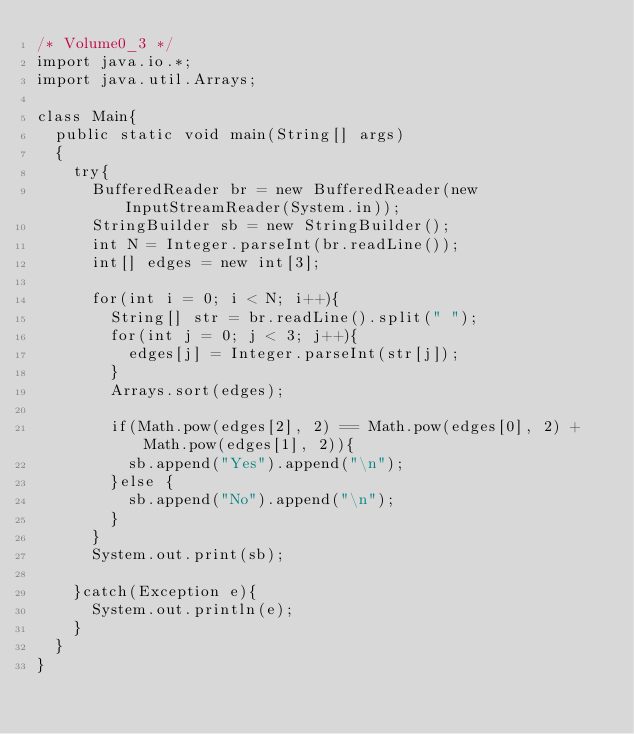Convert code to text. <code><loc_0><loc_0><loc_500><loc_500><_Java_>/* Volume0_3 */
import java.io.*;
import java.util.Arrays;

class Main{
  public static void main(String[] args)
  {
    try{
      BufferedReader br = new BufferedReader(new InputStreamReader(System.in));
      StringBuilder sb = new StringBuilder();
      int N = Integer.parseInt(br.readLine());
      int[] edges = new int[3];

      for(int i = 0; i < N; i++){
        String[] str = br.readLine().split(" ");
        for(int j = 0; j < 3; j++){
          edges[j] = Integer.parseInt(str[j]);
        }
        Arrays.sort(edges);

        if(Math.pow(edges[2], 2) == Math.pow(edges[0], 2) + Math.pow(edges[1], 2)){
          sb.append("Yes").append("\n");
        }else {
          sb.append("No").append("\n");
        }
      }
      System.out.print(sb);

    }catch(Exception e){
      System.out.println(e);
    }
  }
}</code> 